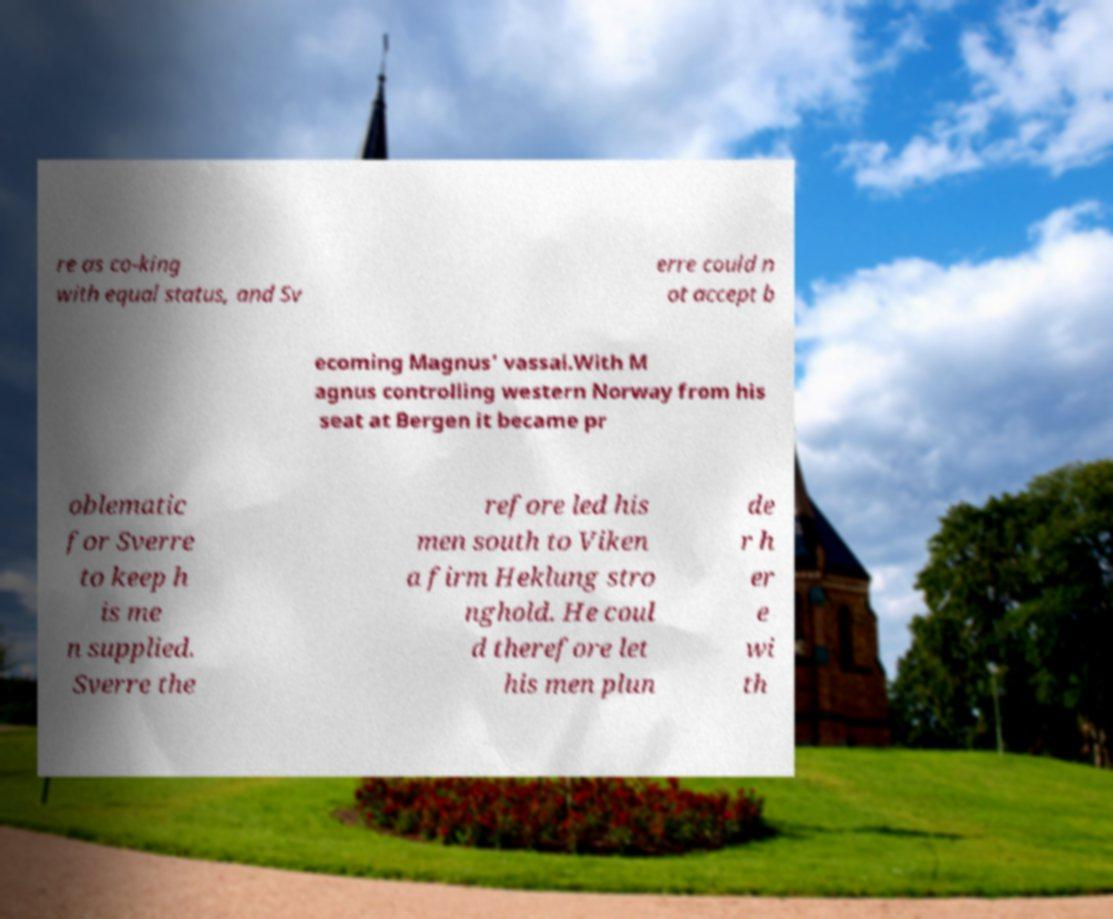Can you accurately transcribe the text from the provided image for me? re as co-king with equal status, and Sv erre could n ot accept b ecoming Magnus' vassal.With M agnus controlling western Norway from his seat at Bergen it became pr oblematic for Sverre to keep h is me n supplied. Sverre the refore led his men south to Viken a firm Heklung stro nghold. He coul d therefore let his men plun de r h er e wi th 